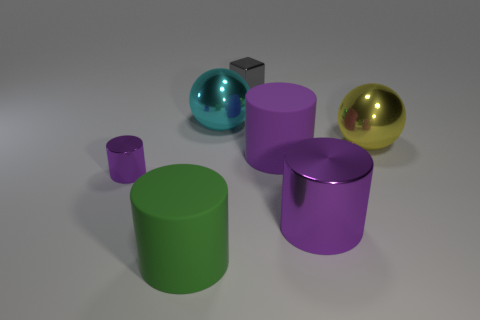How many purple cylinders must be subtracted to get 1 purple cylinders? 2 Subtract all cyan cubes. How many purple cylinders are left? 3 Subtract 1 cylinders. How many cylinders are left? 3 Add 1 small gray objects. How many objects exist? 8 Subtract all balls. How many objects are left? 5 Subtract all big matte objects. Subtract all small shiny things. How many objects are left? 3 Add 2 green rubber things. How many green rubber things are left? 3 Add 6 cylinders. How many cylinders exist? 10 Subtract 1 cyan spheres. How many objects are left? 6 